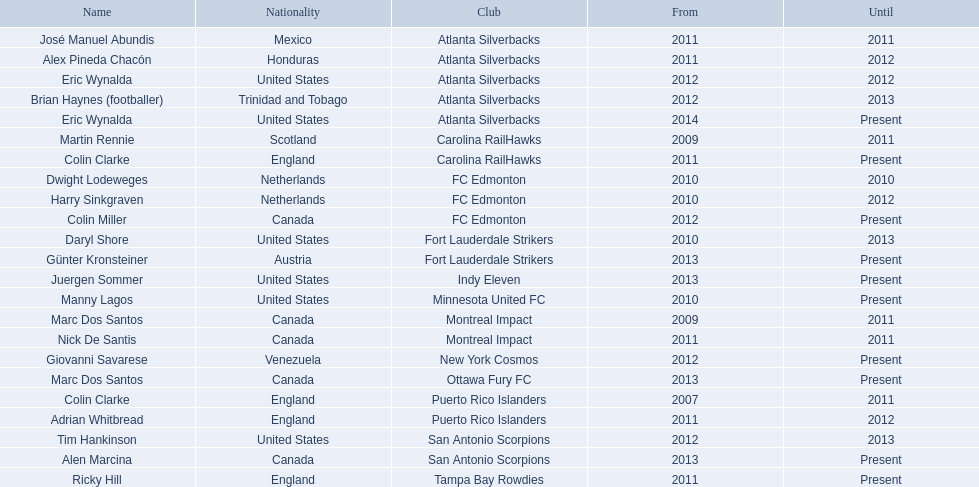When did marc dos santos initiate his coaching role? 2009. Other than marc dos santos, which additional coach started in 2009? Martin Rennie. Who were the coaches involved in coaching during 2010? Martin Rennie, Dwight Lodeweges, Harry Sinkgraven, Daryl Shore, Manny Lagos, Marc Dos Santos, Colin Clarke. Among the 2010 coaches, who were not born in north america? Martin Rennie, Dwight Lodeweges, Harry Sinkgraven, Colin Clarke. Which non-north american coaches in 2010 did not work for fc edmonton? Martin Rennie, Colin Clarke. Which coach, who did not work for fc edmonton in 2010 and was not of north american nationality, had the shortest coaching career? Martin Rennie. 